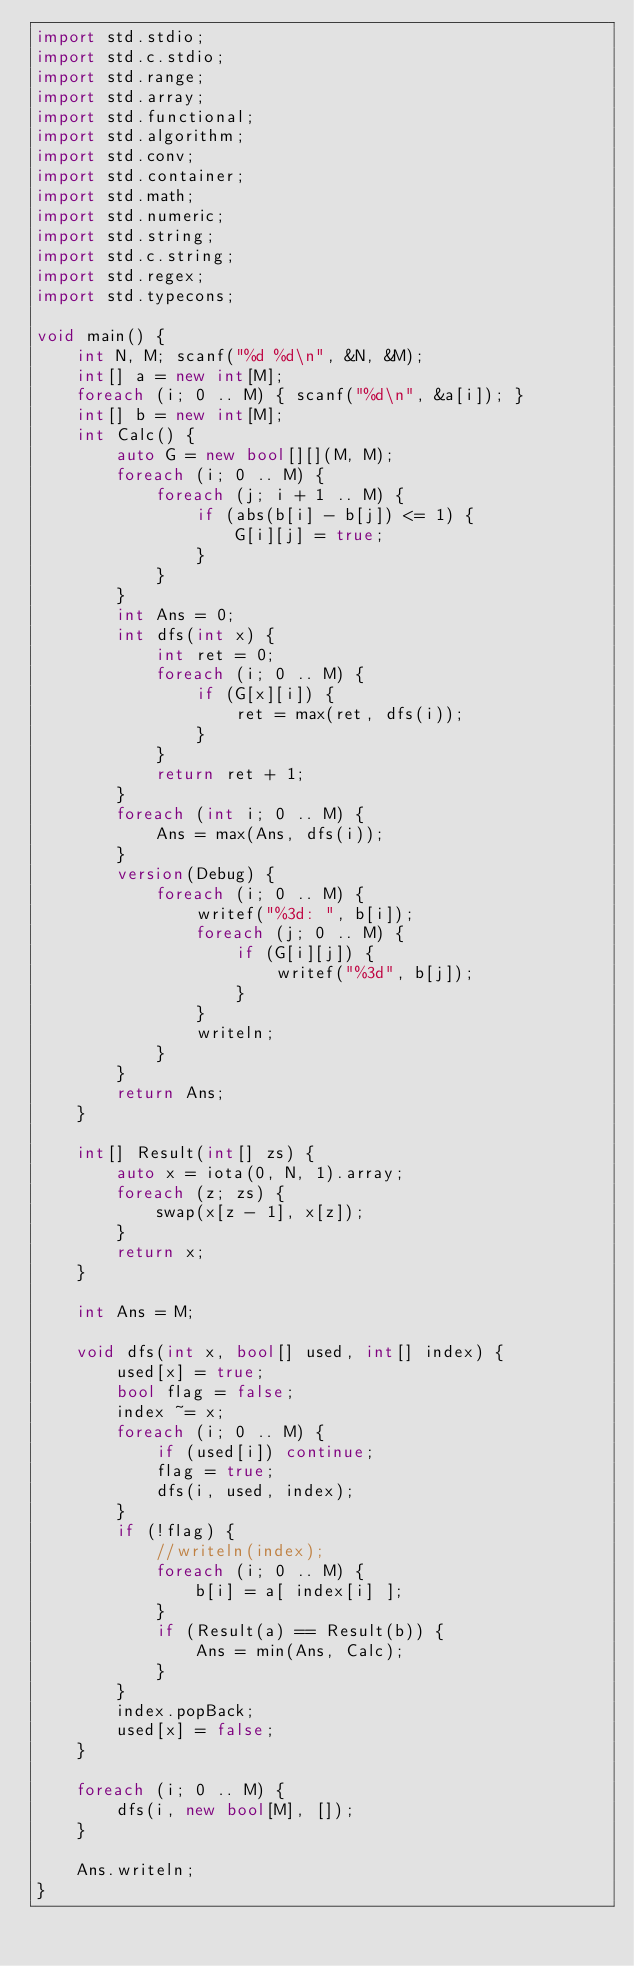<code> <loc_0><loc_0><loc_500><loc_500><_D_>import std.stdio;
import std.c.stdio;
import std.range;
import std.array;
import std.functional;
import std.algorithm;
import std.conv;
import std.container;
import std.math;
import std.numeric;
import std.string;
import std.c.string;
import std.regex;
import std.typecons;

void main() {
    int N, M; scanf("%d %d\n", &N, &M);
    int[] a = new int[M];
    foreach (i; 0 .. M) { scanf("%d\n", &a[i]); }
    int[] b = new int[M];
    int Calc() {
        auto G = new bool[][](M, M);
        foreach (i; 0 .. M) {
            foreach (j; i + 1 .. M) {
                if (abs(b[i] - b[j]) <= 1) {
                    G[i][j] = true;
                }
            }
        }
        int Ans = 0;
        int dfs(int x) {
            int ret = 0;
            foreach (i; 0 .. M) {
                if (G[x][i]) {
                    ret = max(ret, dfs(i));
                }
            }
            return ret + 1;
        }
        foreach (int i; 0 .. M) {
            Ans = max(Ans, dfs(i));
        }
        version(Debug) {
            foreach (i; 0 .. M) {
                writef("%3d: ", b[i]);
                foreach (j; 0 .. M) {
                    if (G[i][j]) {
                        writef("%3d", b[j]);
                    }
                }
                writeln;
            }
        }
        return Ans;
    }

    int[] Result(int[] zs) {
        auto x = iota(0, N, 1).array;
        foreach (z; zs) {
            swap(x[z - 1], x[z]);
        }
        return x;
    }

    int Ans = M;

    void dfs(int x, bool[] used, int[] index) {
        used[x] = true;
        bool flag = false;
        index ~= x;
        foreach (i; 0 .. M) {
            if (used[i]) continue;
            flag = true;
            dfs(i, used, index);
        }
        if (!flag) {
            //writeln(index);
            foreach (i; 0 .. M) {
                b[i] = a[ index[i] ];
            }
            if (Result(a) == Result(b)) {
                Ans = min(Ans, Calc);
            }
        }
        index.popBack;
        used[x] = false;
    }
    
    foreach (i; 0 .. M) {
        dfs(i, new bool[M], []);
    }

    Ans.writeln;
}</code> 